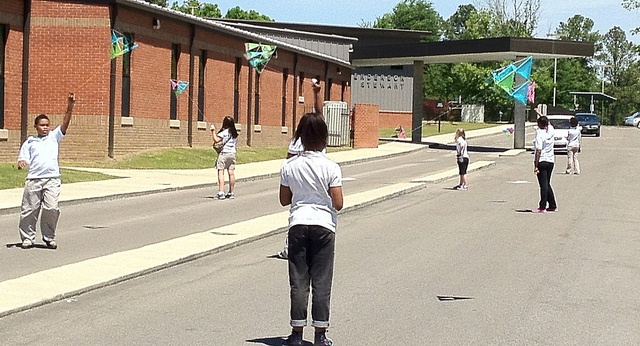Describe the objects in this image and their specific colors. I can see people in maroon, black, white, darkgray, and gray tones, people in maroon, white, gray, and darkgray tones, people in maroon, black, white, darkgray, and gray tones, people in maroon, white, darkgray, gray, and black tones, and kite in maroon, teal, cyan, and green tones in this image. 